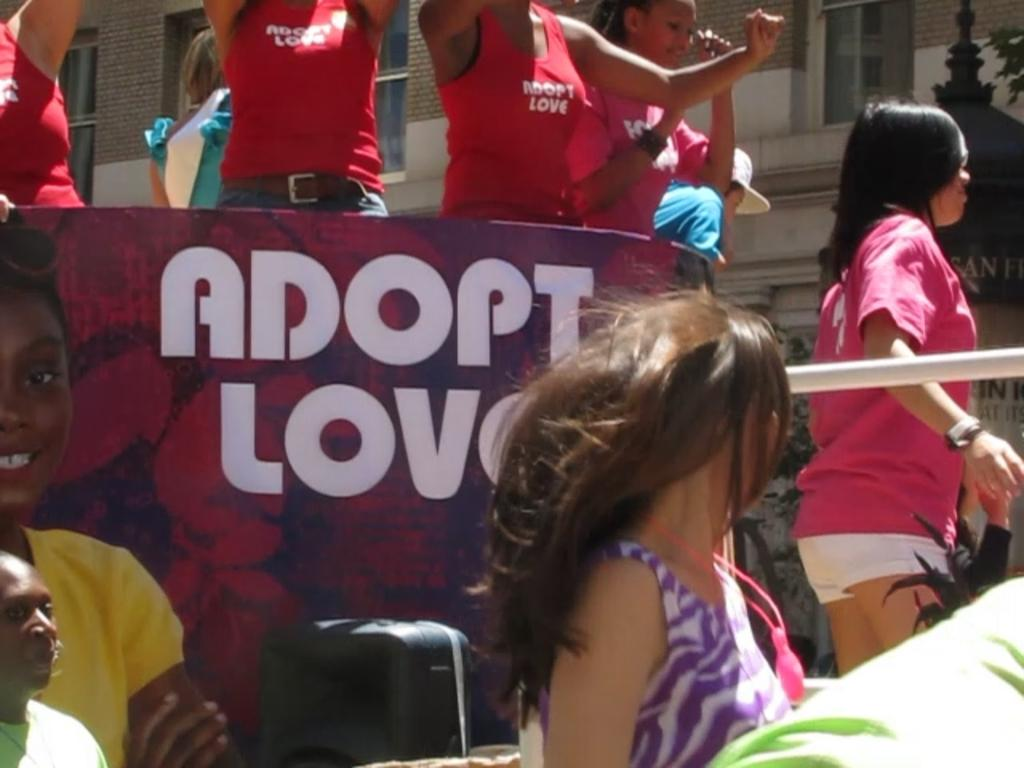<image>
Summarize the visual content of the image. A group of children are riding a parade float that says Adopt Love. 